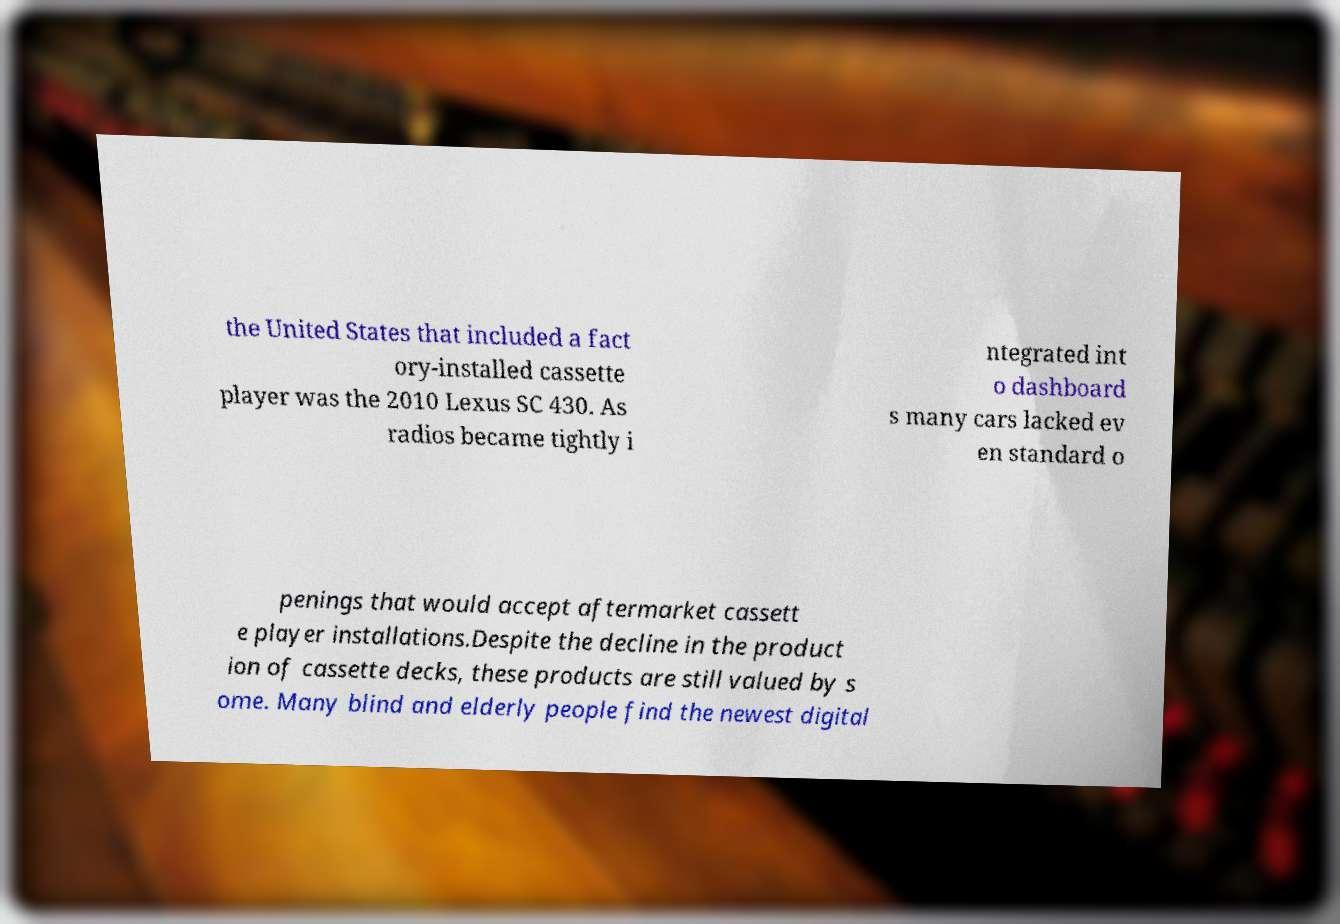There's text embedded in this image that I need extracted. Can you transcribe it verbatim? the United States that included a fact ory-installed cassette player was the 2010 Lexus SC 430. As radios became tightly i ntegrated int o dashboard s many cars lacked ev en standard o penings that would accept aftermarket cassett e player installations.Despite the decline in the product ion of cassette decks, these products are still valued by s ome. Many blind and elderly people find the newest digital 